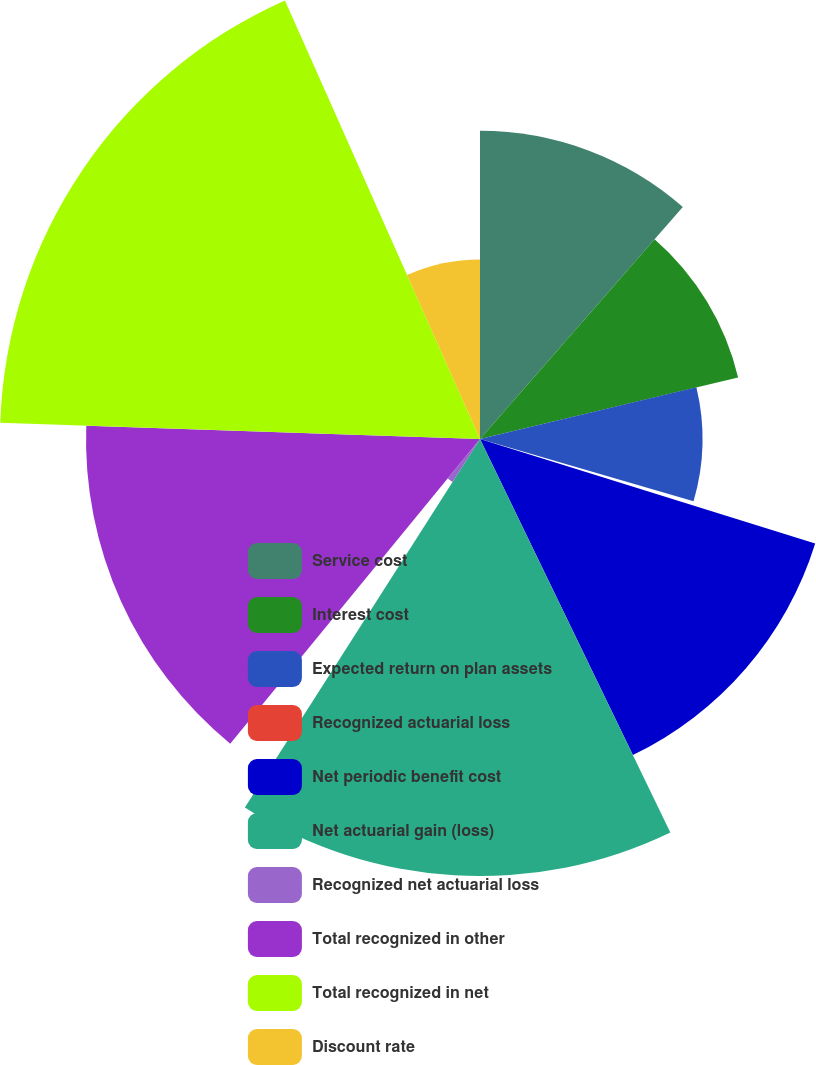Convert chart to OTSL. <chart><loc_0><loc_0><loc_500><loc_500><pie_chart><fcel>Service cost<fcel>Interest cost<fcel>Expected return on plan assets<fcel>Recognized actuarial loss<fcel>Net periodic benefit cost<fcel>Net actuarial gain (loss)<fcel>Recognized net actuarial loss<fcel>Total recognized in other<fcel>Total recognized in net<fcel>Discount rate<nl><fcel>11.43%<fcel>9.84%<fcel>8.25%<fcel>0.29%<fcel>13.02%<fcel>16.21%<fcel>1.89%<fcel>14.61%<fcel>17.8%<fcel>6.66%<nl></chart> 